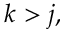Convert formula to latex. <formula><loc_0><loc_0><loc_500><loc_500>k > j ,</formula> 